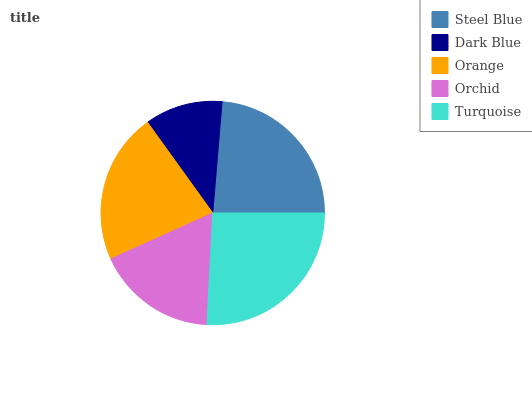Is Dark Blue the minimum?
Answer yes or no. Yes. Is Turquoise the maximum?
Answer yes or no. Yes. Is Orange the minimum?
Answer yes or no. No. Is Orange the maximum?
Answer yes or no. No. Is Orange greater than Dark Blue?
Answer yes or no. Yes. Is Dark Blue less than Orange?
Answer yes or no. Yes. Is Dark Blue greater than Orange?
Answer yes or no. No. Is Orange less than Dark Blue?
Answer yes or no. No. Is Orange the high median?
Answer yes or no. Yes. Is Orange the low median?
Answer yes or no. Yes. Is Turquoise the high median?
Answer yes or no. No. Is Turquoise the low median?
Answer yes or no. No. 